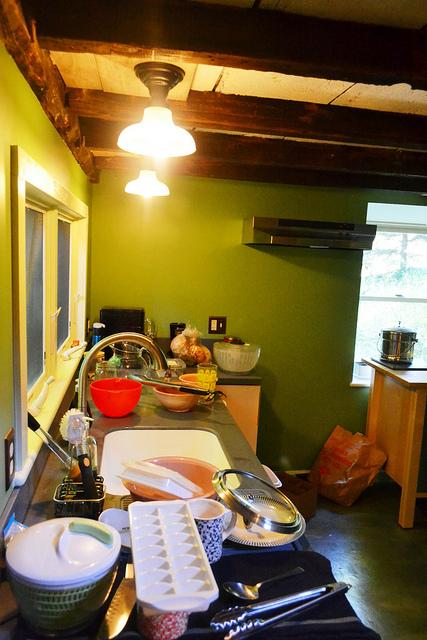What is the electrical device on the wall to the left of the window used for? stove exhaust 